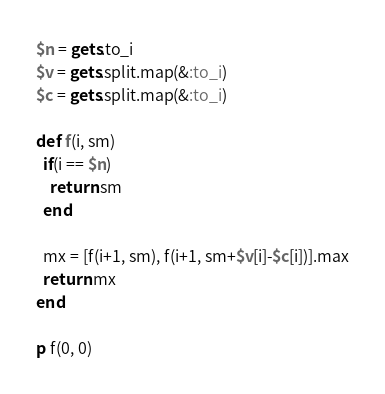<code> <loc_0><loc_0><loc_500><loc_500><_Ruby_>$n = gets.to_i
$v = gets.split.map(&:to_i)
$c = gets.split.map(&:to_i)

def f(i, sm)
  if(i == $n)
    return sm
  end

  mx = [f(i+1, sm), f(i+1, sm+$v[i]-$c[i])].max
  return mx
end

p f(0, 0)
</code> 